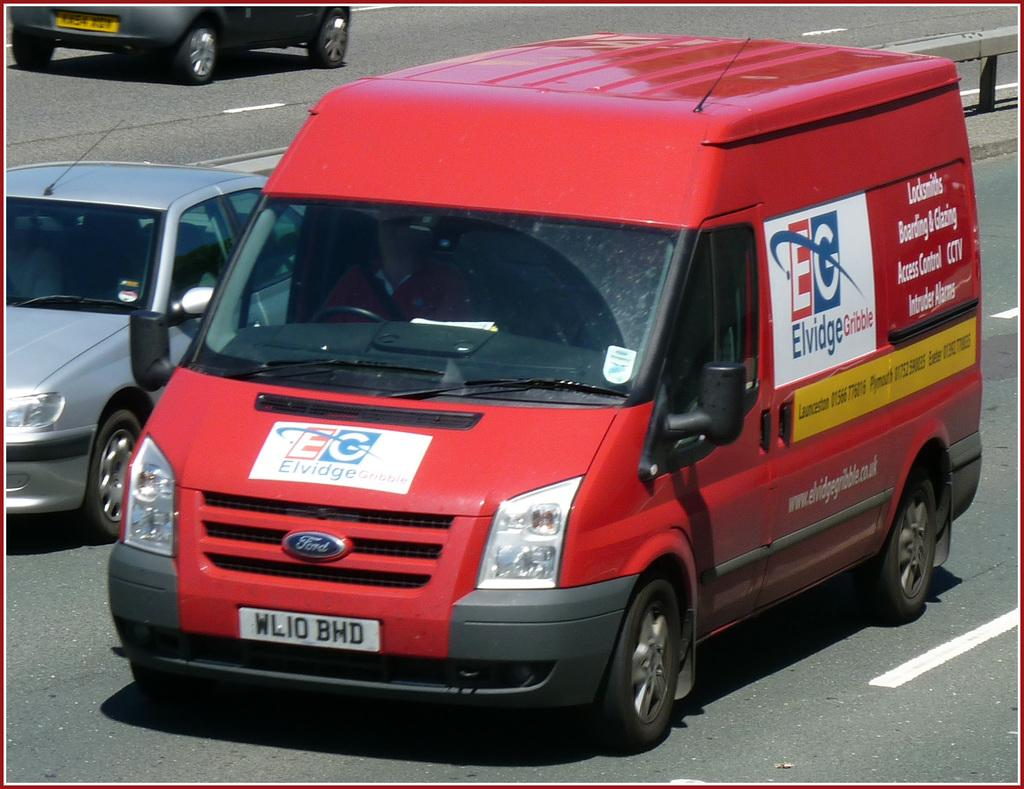<image>
Summarize the visual content of the image. a red EG Ford van on a city street 